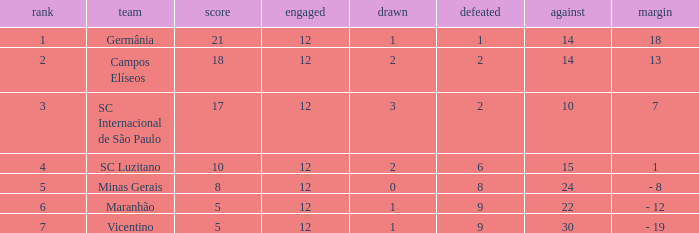What difference has a points greater than 10, and a drawn less than 2? 18.0. 